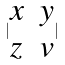<formula> <loc_0><loc_0><loc_500><loc_500>| \begin{matrix} x & y \\ z & v \end{matrix} |</formula> 